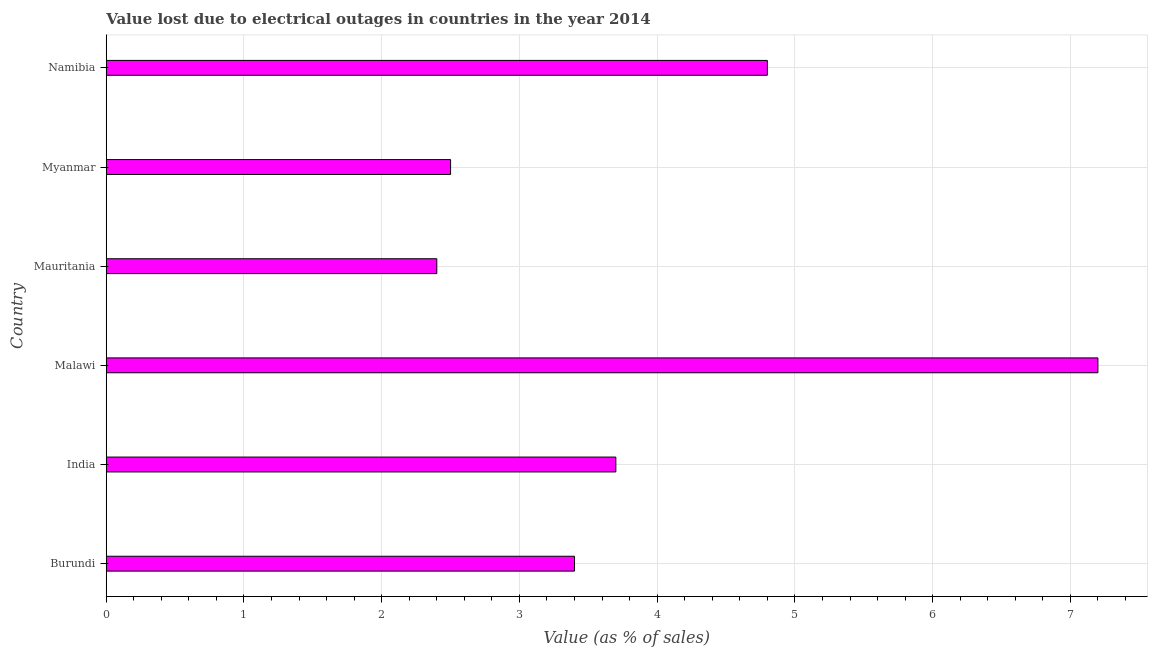Does the graph contain any zero values?
Make the answer very short. No. Does the graph contain grids?
Your response must be concise. Yes. What is the title of the graph?
Ensure brevity in your answer.  Value lost due to electrical outages in countries in the year 2014. What is the label or title of the X-axis?
Offer a terse response. Value (as % of sales). What is the value lost due to electrical outages in Mauritania?
Your response must be concise. 2.4. Across all countries, what is the maximum value lost due to electrical outages?
Give a very brief answer. 7.2. Across all countries, what is the minimum value lost due to electrical outages?
Offer a terse response. 2.4. In which country was the value lost due to electrical outages maximum?
Your response must be concise. Malawi. In which country was the value lost due to electrical outages minimum?
Your answer should be compact. Mauritania. What is the sum of the value lost due to electrical outages?
Ensure brevity in your answer.  24. What is the average value lost due to electrical outages per country?
Your answer should be compact. 4. What is the median value lost due to electrical outages?
Offer a very short reply. 3.55. In how many countries, is the value lost due to electrical outages greater than 6 %?
Keep it short and to the point. 1. What is the ratio of the value lost due to electrical outages in India to that in Mauritania?
Your response must be concise. 1.54. Is the sum of the value lost due to electrical outages in Mauritania and Myanmar greater than the maximum value lost due to electrical outages across all countries?
Ensure brevity in your answer.  No. What is the difference between the highest and the lowest value lost due to electrical outages?
Offer a terse response. 4.8. In how many countries, is the value lost due to electrical outages greater than the average value lost due to electrical outages taken over all countries?
Provide a succinct answer. 2. How many countries are there in the graph?
Keep it short and to the point. 6. What is the Value (as % of sales) in Malawi?
Provide a short and direct response. 7.2. What is the Value (as % of sales) of Myanmar?
Ensure brevity in your answer.  2.5. What is the Value (as % of sales) in Namibia?
Your answer should be compact. 4.8. What is the difference between the Value (as % of sales) in India and Myanmar?
Ensure brevity in your answer.  1.2. What is the difference between the Value (as % of sales) in India and Namibia?
Make the answer very short. -1.1. What is the difference between the Value (as % of sales) in Malawi and Mauritania?
Keep it short and to the point. 4.8. What is the difference between the Value (as % of sales) in Mauritania and Myanmar?
Provide a short and direct response. -0.1. What is the difference between the Value (as % of sales) in Mauritania and Namibia?
Provide a succinct answer. -2.4. What is the ratio of the Value (as % of sales) in Burundi to that in India?
Ensure brevity in your answer.  0.92. What is the ratio of the Value (as % of sales) in Burundi to that in Malawi?
Your response must be concise. 0.47. What is the ratio of the Value (as % of sales) in Burundi to that in Mauritania?
Offer a very short reply. 1.42. What is the ratio of the Value (as % of sales) in Burundi to that in Myanmar?
Make the answer very short. 1.36. What is the ratio of the Value (as % of sales) in Burundi to that in Namibia?
Provide a succinct answer. 0.71. What is the ratio of the Value (as % of sales) in India to that in Malawi?
Keep it short and to the point. 0.51. What is the ratio of the Value (as % of sales) in India to that in Mauritania?
Offer a terse response. 1.54. What is the ratio of the Value (as % of sales) in India to that in Myanmar?
Make the answer very short. 1.48. What is the ratio of the Value (as % of sales) in India to that in Namibia?
Make the answer very short. 0.77. What is the ratio of the Value (as % of sales) in Malawi to that in Myanmar?
Keep it short and to the point. 2.88. What is the ratio of the Value (as % of sales) in Malawi to that in Namibia?
Your answer should be very brief. 1.5. What is the ratio of the Value (as % of sales) in Mauritania to that in Myanmar?
Make the answer very short. 0.96. What is the ratio of the Value (as % of sales) in Mauritania to that in Namibia?
Provide a succinct answer. 0.5. What is the ratio of the Value (as % of sales) in Myanmar to that in Namibia?
Your answer should be very brief. 0.52. 